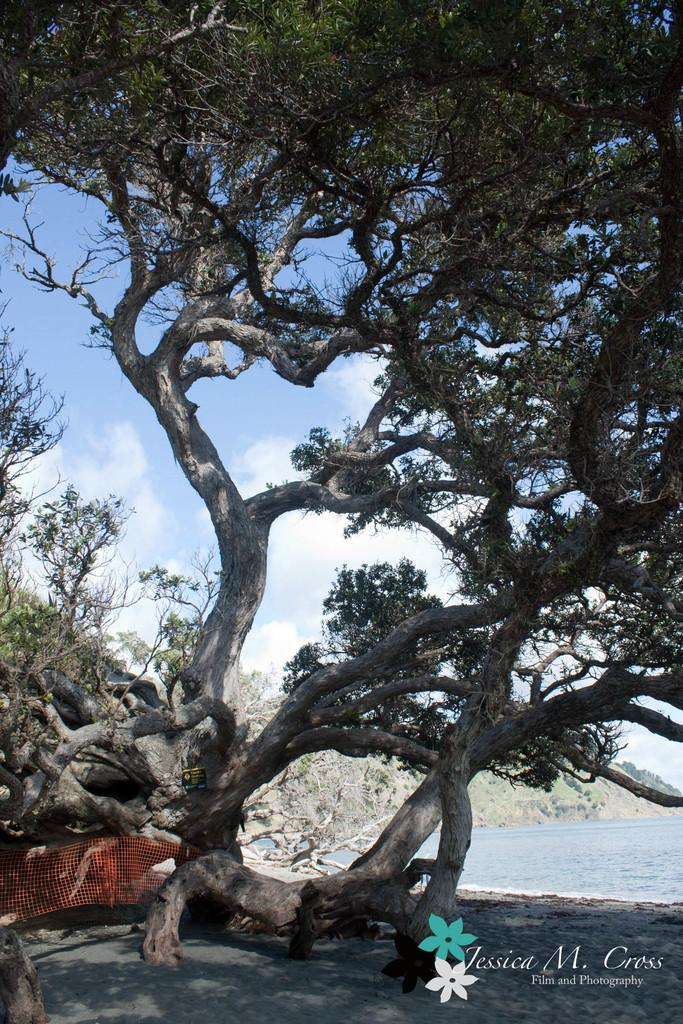What type of natural elements can be seen in the image? There are trees and water visible in the image. What part of the natural environment is visible in the image? The sky is also visible in the image. What other objects can be seen in the image besides the natural elements? There are other objects in the image. Is there any text or marking on the image? Yes, there is a watermark on the bottom right side of the image. Can you describe the process of the giants in the image? There are no giants present in the image, so it is not possible to describe any process involving them. 